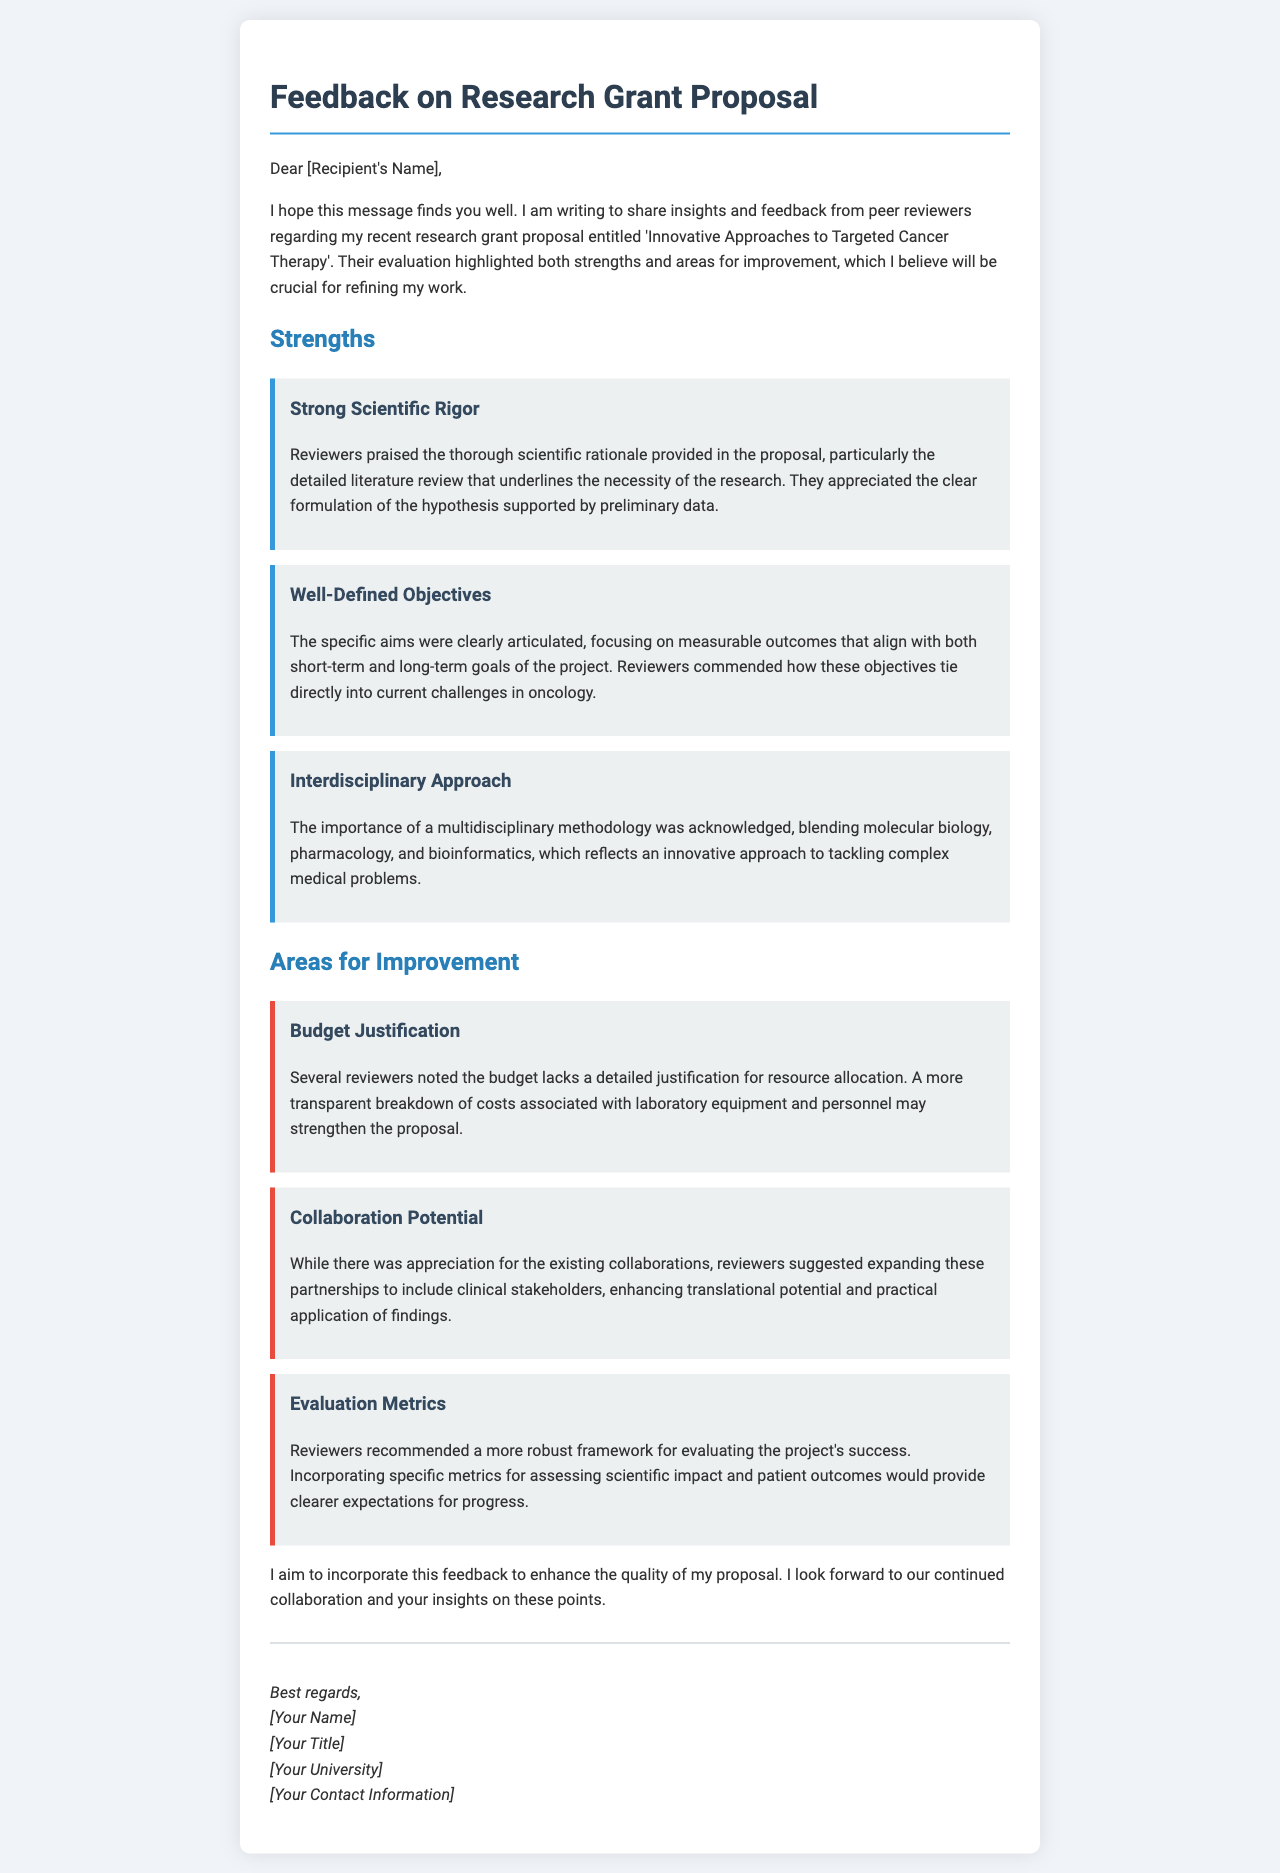What is the title of the research grant proposal? The title of the research grant proposal is provided in the document as 'Innovative Approaches to Targeted Cancer Therapy'.
Answer: Innovative Approaches to Targeted Cancer Therapy Who is the recipient of the feedback? The recipient's name is addressed in the salutation, indicated as '[Recipient's Name]'.
Answer: [Recipient's Name] What strength is associated with budget justification? The strength associated with budget justification is not explicitly mentioned, as it is listed under areas for improvement in the document.
Answer: N/A How many strengths are highlighted in the proposal feedback? The document lists three strengths regarding the research grant proposal.
Answer: 3 What specific area needs improvement regarding collaboration? The document notes that expanding partnerships to include clinical stakeholders needs improvement.
Answer: Collaboration Potential What aspect of the objectives received commendation? Reviewers commended how the specific aims focused on measurable outcomes that align with current challenges in oncology.
Answer: Well-Defined Objectives What is a suggested evaluation metric mentioned in the feedback? The feedback suggests incorporating specific metrics for assessing scientific impact and patient outcomes.
Answer: Evaluation Metrics How did reviewers describe the interdisciplinary approach? The interdisciplinary approach was acknowledged as blending molecular biology, pharmacology, and bioinformatics.
Answer: Interdisciplinary Approach 